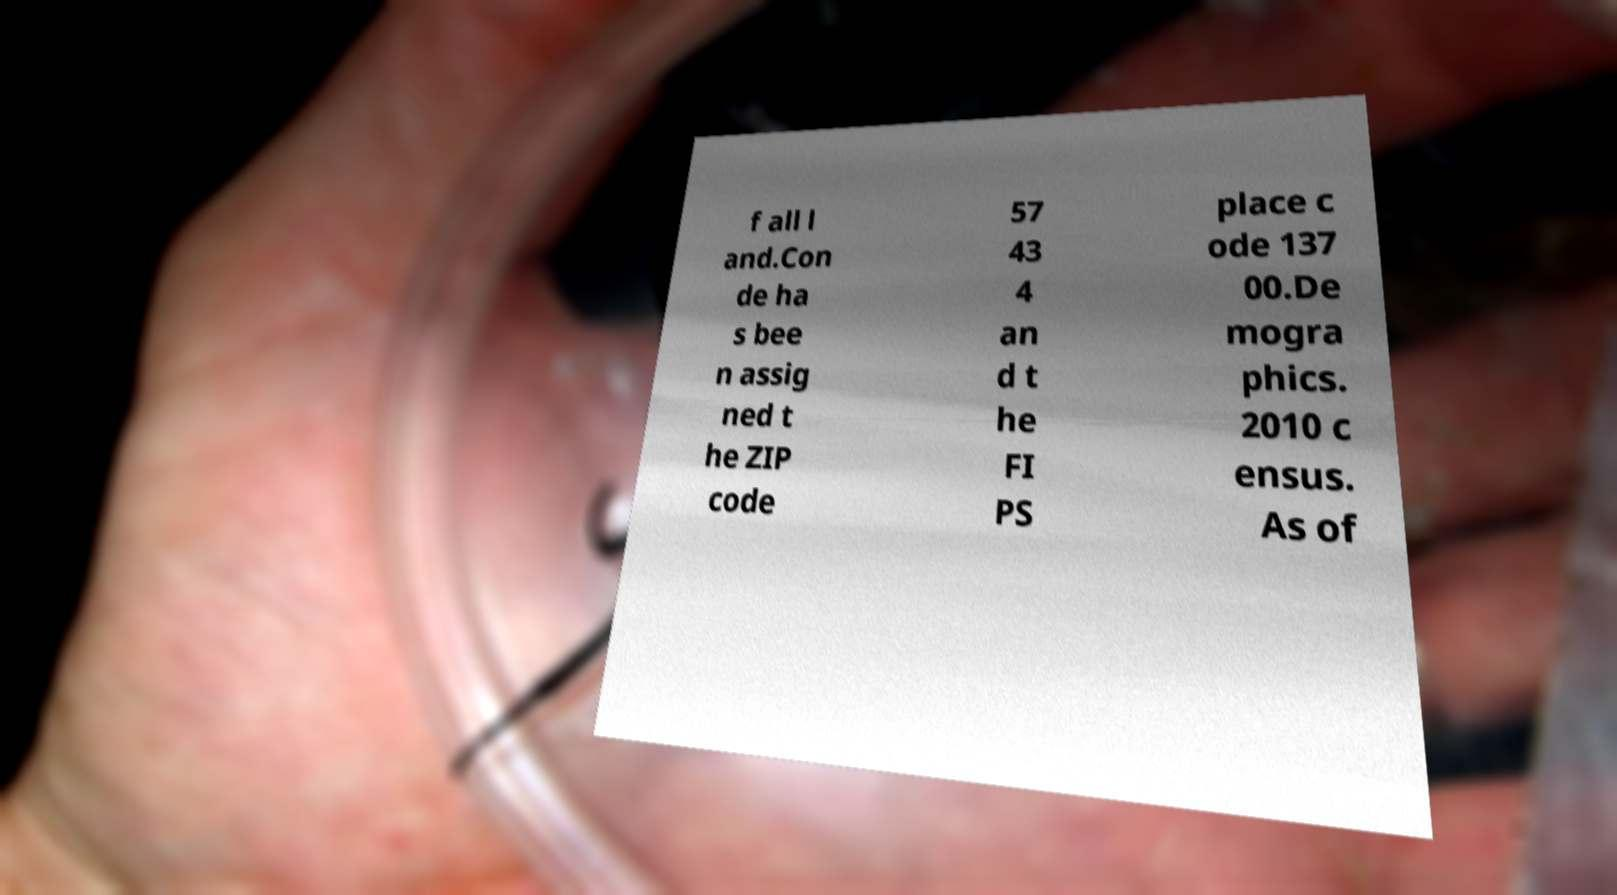Please identify and transcribe the text found in this image. f all l and.Con de ha s bee n assig ned t he ZIP code 57 43 4 an d t he FI PS place c ode 137 00.De mogra phics. 2010 c ensus. As of 